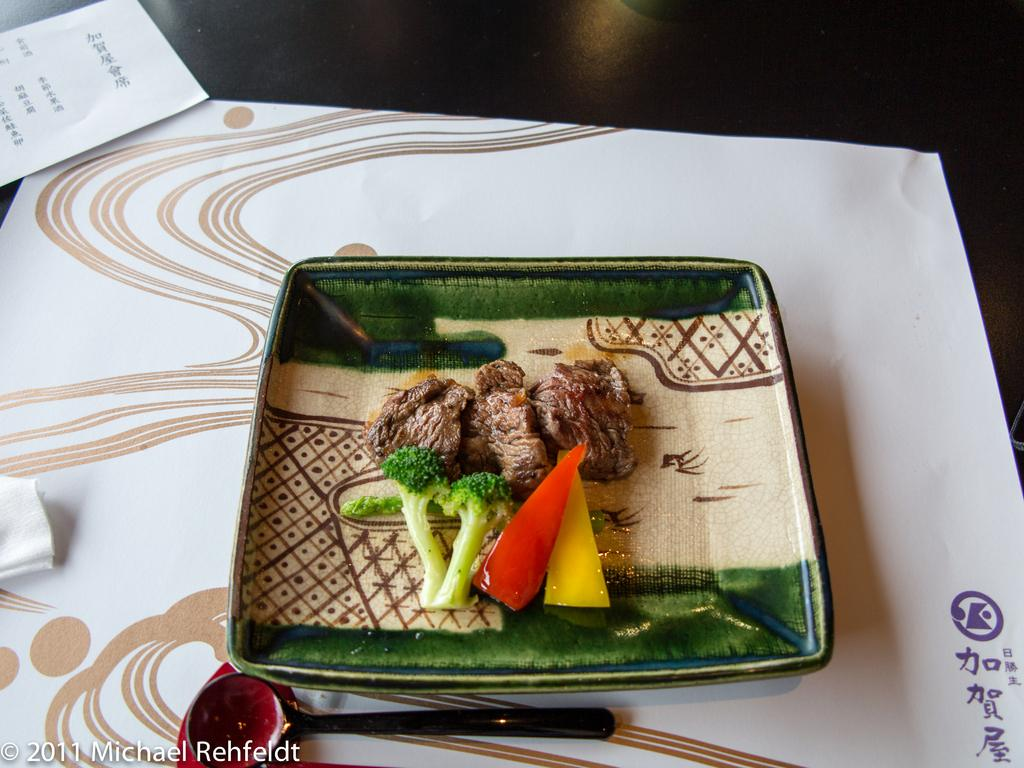What is on the table in the image? There is a plate, a spoon, a paper napkin, and a paper with text on the table in the image. What is on the plate? A: There is food on the plate in the image. What might be used to eat the food on the plate? The spoon on the table can be used to eat the food on the plate. What is the paper with text on the table used for? The paper with text on the table might contain information about the food or the meal. What type of button is attached to the horse's saddle in the image? There is no horse or button present in the image; it only features a plate, food, a spoon, a paper napkin, and a paper with text on a table. 